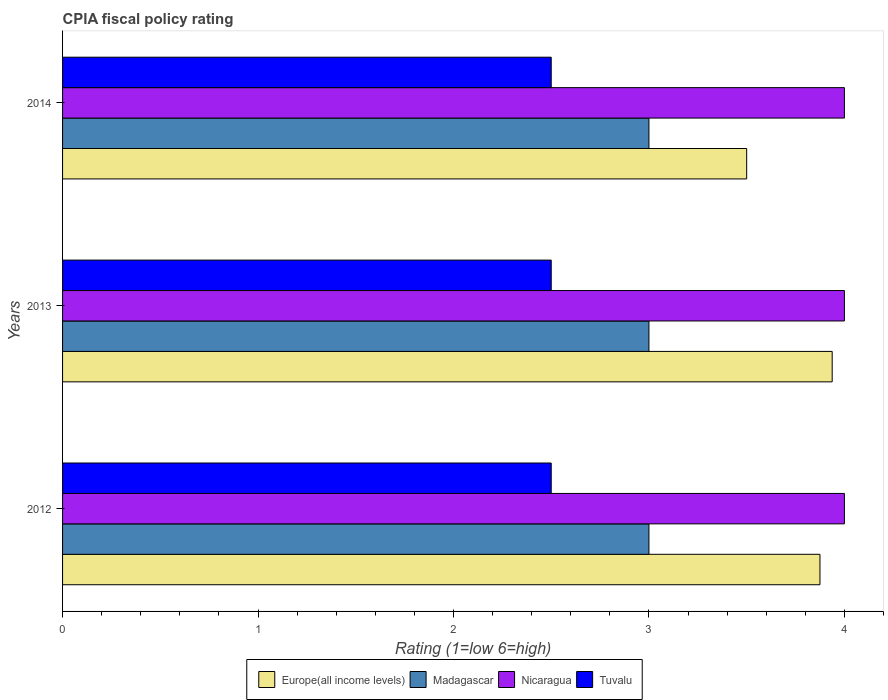How many groups of bars are there?
Your response must be concise. 3. Are the number of bars per tick equal to the number of legend labels?
Offer a terse response. Yes. In how many cases, is the number of bars for a given year not equal to the number of legend labels?
Give a very brief answer. 0. What is the CPIA rating in Tuvalu in 2014?
Your response must be concise. 2.5. Across all years, what is the maximum CPIA rating in Nicaragua?
Give a very brief answer. 4. Across all years, what is the minimum CPIA rating in Tuvalu?
Provide a succinct answer. 2.5. In which year was the CPIA rating in Nicaragua minimum?
Provide a short and direct response. 2012. What is the difference between the CPIA rating in Europe(all income levels) in 2014 and the CPIA rating in Madagascar in 2013?
Your answer should be very brief. 0.5. What is the average CPIA rating in Tuvalu per year?
Your answer should be very brief. 2.5. In how many years, is the CPIA rating in Tuvalu greater than 1.6 ?
Offer a terse response. 3. What is the ratio of the CPIA rating in Madagascar in 2012 to that in 2013?
Your answer should be compact. 1. Is the CPIA rating in Europe(all income levels) in 2012 less than that in 2013?
Your response must be concise. Yes. What is the difference between the highest and the second highest CPIA rating in Europe(all income levels)?
Provide a short and direct response. 0.06. Is the sum of the CPIA rating in Europe(all income levels) in 2013 and 2014 greater than the maximum CPIA rating in Tuvalu across all years?
Your answer should be compact. Yes. Is it the case that in every year, the sum of the CPIA rating in Madagascar and CPIA rating in Tuvalu is greater than the sum of CPIA rating in Europe(all income levels) and CPIA rating in Nicaragua?
Offer a very short reply. No. What does the 1st bar from the top in 2012 represents?
Provide a short and direct response. Tuvalu. What does the 1st bar from the bottom in 2014 represents?
Offer a very short reply. Europe(all income levels). Does the graph contain any zero values?
Make the answer very short. No. Where does the legend appear in the graph?
Your answer should be very brief. Bottom center. How many legend labels are there?
Make the answer very short. 4. How are the legend labels stacked?
Give a very brief answer. Horizontal. What is the title of the graph?
Offer a very short reply. CPIA fiscal policy rating. Does "Uruguay" appear as one of the legend labels in the graph?
Your response must be concise. No. What is the Rating (1=low 6=high) of Europe(all income levels) in 2012?
Your answer should be very brief. 3.88. What is the Rating (1=low 6=high) in Madagascar in 2012?
Your response must be concise. 3. What is the Rating (1=low 6=high) of Europe(all income levels) in 2013?
Your response must be concise. 3.94. What is the Rating (1=low 6=high) in Europe(all income levels) in 2014?
Make the answer very short. 3.5. What is the Rating (1=low 6=high) in Madagascar in 2014?
Ensure brevity in your answer.  3. What is the Rating (1=low 6=high) in Nicaragua in 2014?
Your answer should be very brief. 4. What is the Rating (1=low 6=high) of Tuvalu in 2014?
Your answer should be very brief. 2.5. Across all years, what is the maximum Rating (1=low 6=high) of Europe(all income levels)?
Offer a terse response. 3.94. Across all years, what is the maximum Rating (1=low 6=high) in Madagascar?
Give a very brief answer. 3. Across all years, what is the minimum Rating (1=low 6=high) of Europe(all income levels)?
Ensure brevity in your answer.  3.5. Across all years, what is the minimum Rating (1=low 6=high) of Madagascar?
Your answer should be compact. 3. Across all years, what is the minimum Rating (1=low 6=high) in Nicaragua?
Make the answer very short. 4. Across all years, what is the minimum Rating (1=low 6=high) of Tuvalu?
Ensure brevity in your answer.  2.5. What is the total Rating (1=low 6=high) in Europe(all income levels) in the graph?
Make the answer very short. 11.31. What is the difference between the Rating (1=low 6=high) of Europe(all income levels) in 2012 and that in 2013?
Make the answer very short. -0.06. What is the difference between the Rating (1=low 6=high) of Madagascar in 2012 and that in 2013?
Provide a succinct answer. 0. What is the difference between the Rating (1=low 6=high) in Nicaragua in 2012 and that in 2013?
Give a very brief answer. 0. What is the difference between the Rating (1=low 6=high) of Nicaragua in 2012 and that in 2014?
Ensure brevity in your answer.  0. What is the difference between the Rating (1=low 6=high) of Tuvalu in 2012 and that in 2014?
Offer a terse response. 0. What is the difference between the Rating (1=low 6=high) in Europe(all income levels) in 2013 and that in 2014?
Your answer should be compact. 0.44. What is the difference between the Rating (1=low 6=high) in Europe(all income levels) in 2012 and the Rating (1=low 6=high) in Madagascar in 2013?
Provide a short and direct response. 0.88. What is the difference between the Rating (1=low 6=high) in Europe(all income levels) in 2012 and the Rating (1=low 6=high) in Nicaragua in 2013?
Give a very brief answer. -0.12. What is the difference between the Rating (1=low 6=high) of Europe(all income levels) in 2012 and the Rating (1=low 6=high) of Tuvalu in 2013?
Provide a short and direct response. 1.38. What is the difference between the Rating (1=low 6=high) of Madagascar in 2012 and the Rating (1=low 6=high) of Nicaragua in 2013?
Offer a terse response. -1. What is the difference between the Rating (1=low 6=high) of Madagascar in 2012 and the Rating (1=low 6=high) of Tuvalu in 2013?
Offer a terse response. 0.5. What is the difference between the Rating (1=low 6=high) of Europe(all income levels) in 2012 and the Rating (1=low 6=high) of Madagascar in 2014?
Offer a very short reply. 0.88. What is the difference between the Rating (1=low 6=high) in Europe(all income levels) in 2012 and the Rating (1=low 6=high) in Nicaragua in 2014?
Keep it short and to the point. -0.12. What is the difference between the Rating (1=low 6=high) in Europe(all income levels) in 2012 and the Rating (1=low 6=high) in Tuvalu in 2014?
Provide a short and direct response. 1.38. What is the difference between the Rating (1=low 6=high) of Madagascar in 2012 and the Rating (1=low 6=high) of Nicaragua in 2014?
Provide a short and direct response. -1. What is the difference between the Rating (1=low 6=high) in Madagascar in 2012 and the Rating (1=low 6=high) in Tuvalu in 2014?
Provide a short and direct response. 0.5. What is the difference between the Rating (1=low 6=high) in Europe(all income levels) in 2013 and the Rating (1=low 6=high) in Nicaragua in 2014?
Give a very brief answer. -0.06. What is the difference between the Rating (1=low 6=high) in Europe(all income levels) in 2013 and the Rating (1=low 6=high) in Tuvalu in 2014?
Your answer should be very brief. 1.44. What is the difference between the Rating (1=low 6=high) in Madagascar in 2013 and the Rating (1=low 6=high) in Nicaragua in 2014?
Your answer should be very brief. -1. What is the difference between the Rating (1=low 6=high) in Madagascar in 2013 and the Rating (1=low 6=high) in Tuvalu in 2014?
Make the answer very short. 0.5. What is the average Rating (1=low 6=high) in Europe(all income levels) per year?
Offer a very short reply. 3.77. What is the average Rating (1=low 6=high) of Nicaragua per year?
Ensure brevity in your answer.  4. What is the average Rating (1=low 6=high) of Tuvalu per year?
Your answer should be very brief. 2.5. In the year 2012, what is the difference between the Rating (1=low 6=high) of Europe(all income levels) and Rating (1=low 6=high) of Madagascar?
Offer a very short reply. 0.88. In the year 2012, what is the difference between the Rating (1=low 6=high) in Europe(all income levels) and Rating (1=low 6=high) in Nicaragua?
Offer a terse response. -0.12. In the year 2012, what is the difference between the Rating (1=low 6=high) in Europe(all income levels) and Rating (1=low 6=high) in Tuvalu?
Offer a very short reply. 1.38. In the year 2012, what is the difference between the Rating (1=low 6=high) in Madagascar and Rating (1=low 6=high) in Nicaragua?
Ensure brevity in your answer.  -1. In the year 2012, what is the difference between the Rating (1=low 6=high) of Madagascar and Rating (1=low 6=high) of Tuvalu?
Offer a terse response. 0.5. In the year 2012, what is the difference between the Rating (1=low 6=high) of Nicaragua and Rating (1=low 6=high) of Tuvalu?
Your answer should be very brief. 1.5. In the year 2013, what is the difference between the Rating (1=low 6=high) in Europe(all income levels) and Rating (1=low 6=high) in Nicaragua?
Your answer should be very brief. -0.06. In the year 2013, what is the difference between the Rating (1=low 6=high) in Europe(all income levels) and Rating (1=low 6=high) in Tuvalu?
Offer a terse response. 1.44. In the year 2013, what is the difference between the Rating (1=low 6=high) of Madagascar and Rating (1=low 6=high) of Tuvalu?
Your answer should be very brief. 0.5. In the year 2013, what is the difference between the Rating (1=low 6=high) of Nicaragua and Rating (1=low 6=high) of Tuvalu?
Provide a succinct answer. 1.5. In the year 2014, what is the difference between the Rating (1=low 6=high) in Europe(all income levels) and Rating (1=low 6=high) in Nicaragua?
Make the answer very short. -0.5. In the year 2014, what is the difference between the Rating (1=low 6=high) of Europe(all income levels) and Rating (1=low 6=high) of Tuvalu?
Provide a short and direct response. 1. In the year 2014, what is the difference between the Rating (1=low 6=high) of Nicaragua and Rating (1=low 6=high) of Tuvalu?
Offer a very short reply. 1.5. What is the ratio of the Rating (1=low 6=high) in Europe(all income levels) in 2012 to that in 2013?
Keep it short and to the point. 0.98. What is the ratio of the Rating (1=low 6=high) in Madagascar in 2012 to that in 2013?
Your response must be concise. 1. What is the ratio of the Rating (1=low 6=high) in Europe(all income levels) in 2012 to that in 2014?
Provide a succinct answer. 1.11. What is the ratio of the Rating (1=low 6=high) of Europe(all income levels) in 2013 to that in 2014?
Provide a succinct answer. 1.12. What is the difference between the highest and the second highest Rating (1=low 6=high) in Europe(all income levels)?
Provide a short and direct response. 0.06. What is the difference between the highest and the second highest Rating (1=low 6=high) in Madagascar?
Your answer should be compact. 0. What is the difference between the highest and the second highest Rating (1=low 6=high) in Nicaragua?
Your response must be concise. 0. What is the difference between the highest and the second highest Rating (1=low 6=high) in Tuvalu?
Offer a very short reply. 0. What is the difference between the highest and the lowest Rating (1=low 6=high) in Europe(all income levels)?
Offer a terse response. 0.44. What is the difference between the highest and the lowest Rating (1=low 6=high) of Tuvalu?
Your response must be concise. 0. 